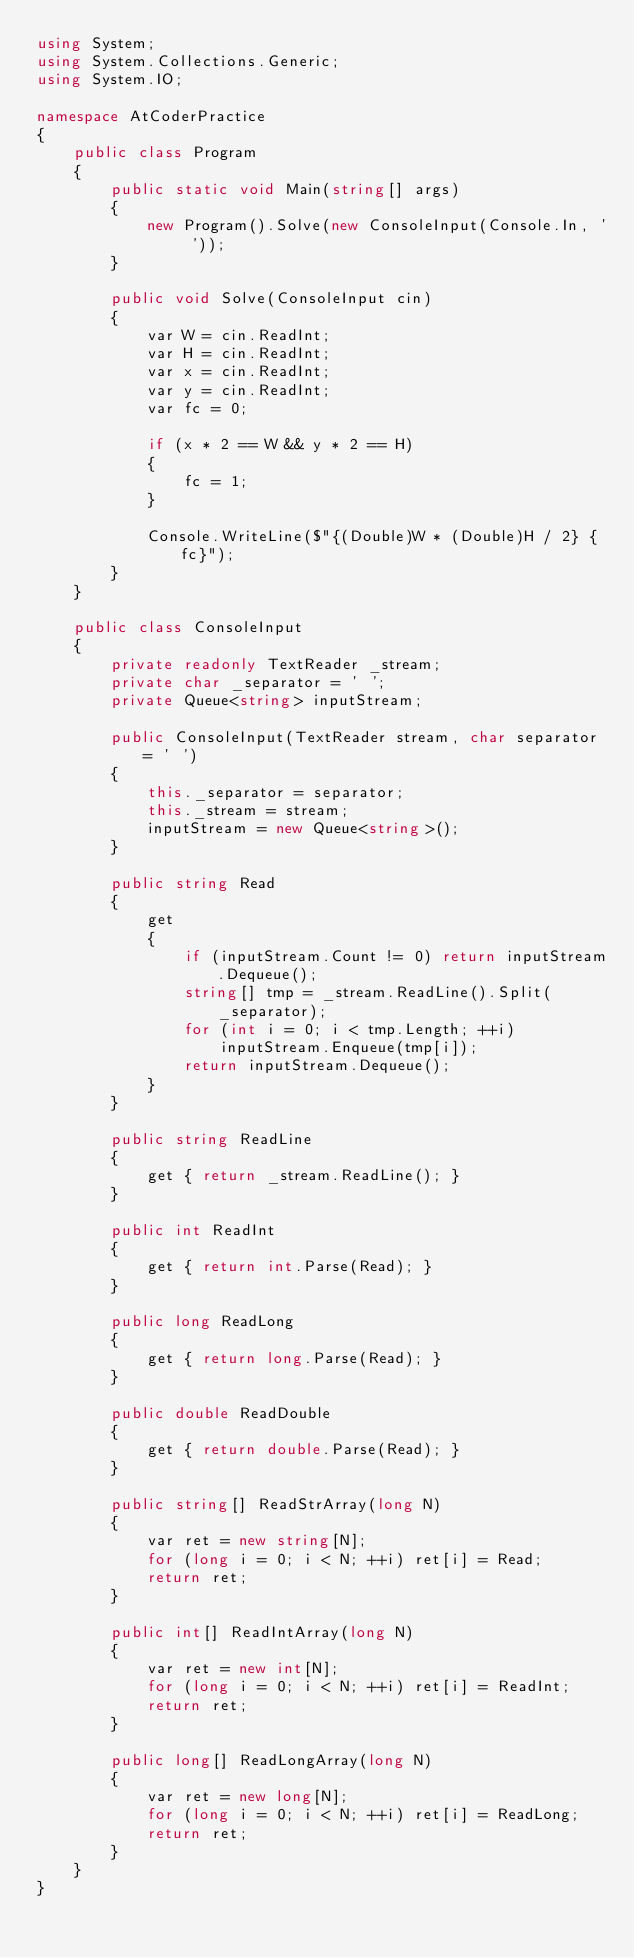Convert code to text. <code><loc_0><loc_0><loc_500><loc_500><_C#_>using System;
using System.Collections.Generic;
using System.IO;

namespace AtCoderPractice
{
    public class Program
    {
        public static void Main(string[] args)
        {
            new Program().Solve(new ConsoleInput(Console.In, ' '));
        }

        public void Solve(ConsoleInput cin)
        {
            var W = cin.ReadInt;
            var H = cin.ReadInt;
            var x = cin.ReadInt;
            var y = cin.ReadInt;
            var fc = 0;

            if (x * 2 == W && y * 2 == H)
            {
                fc = 1;
            }
            
            Console.WriteLine($"{(Double)W * (Double)H / 2} {fc}");
        }
    }

    public class ConsoleInput
    {
        private readonly TextReader _stream;
        private char _separator = ' ';
        private Queue<string> inputStream;

        public ConsoleInput(TextReader stream, char separator = ' ')
        {
            this._separator = separator;
            this._stream = stream;
            inputStream = new Queue<string>();
        }

        public string Read
        {
            get
            {
                if (inputStream.Count != 0) return inputStream.Dequeue();
                string[] tmp = _stream.ReadLine().Split(_separator);
                for (int i = 0; i < tmp.Length; ++i)
                    inputStream.Enqueue(tmp[i]);
                return inputStream.Dequeue();
            }
        }

        public string ReadLine
        {
            get { return _stream.ReadLine(); }
        }

        public int ReadInt
        {
            get { return int.Parse(Read); }
        }

        public long ReadLong
        {
            get { return long.Parse(Read); }
        }

        public double ReadDouble
        {
            get { return double.Parse(Read); }
        }

        public string[] ReadStrArray(long N)
        {
            var ret = new string[N];
            for (long i = 0; i < N; ++i) ret[i] = Read;
            return ret;
        }

        public int[] ReadIntArray(long N)
        {
            var ret = new int[N];
            for (long i = 0; i < N; ++i) ret[i] = ReadInt;
            return ret;
        }

        public long[] ReadLongArray(long N)
        {
            var ret = new long[N];
            for (long i = 0; i < N; ++i) ret[i] = ReadLong;
            return ret;
        }
    }
}</code> 